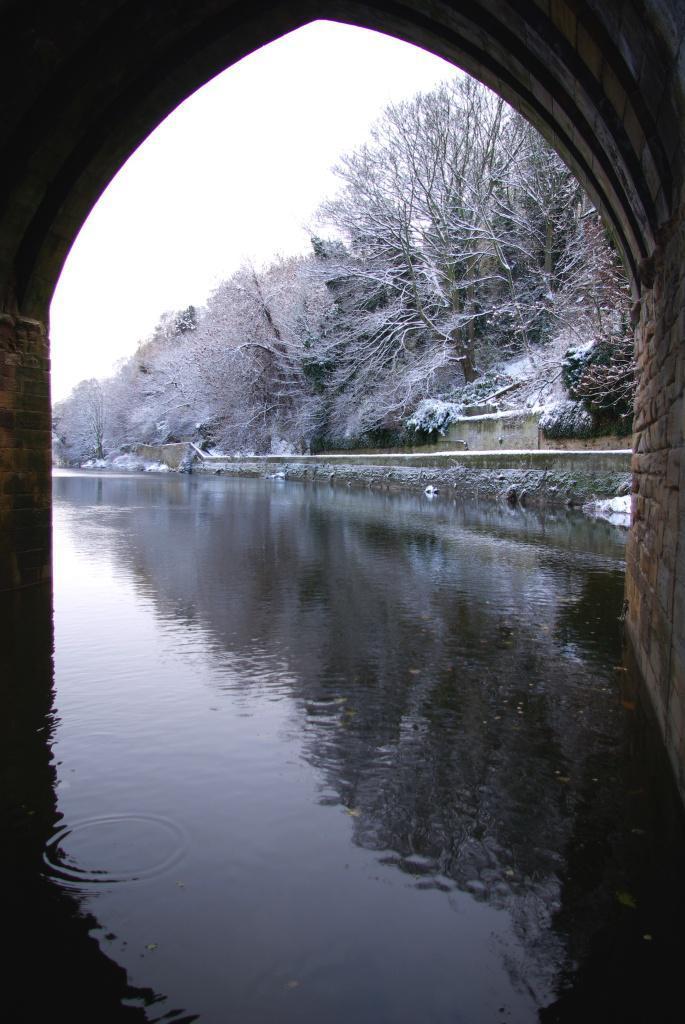Can you describe this image briefly? In the center of the image we can see a bridge, water and wall. In the background of the image we can see the trees which are covered with ice. At the top of the image we can see the sky. 